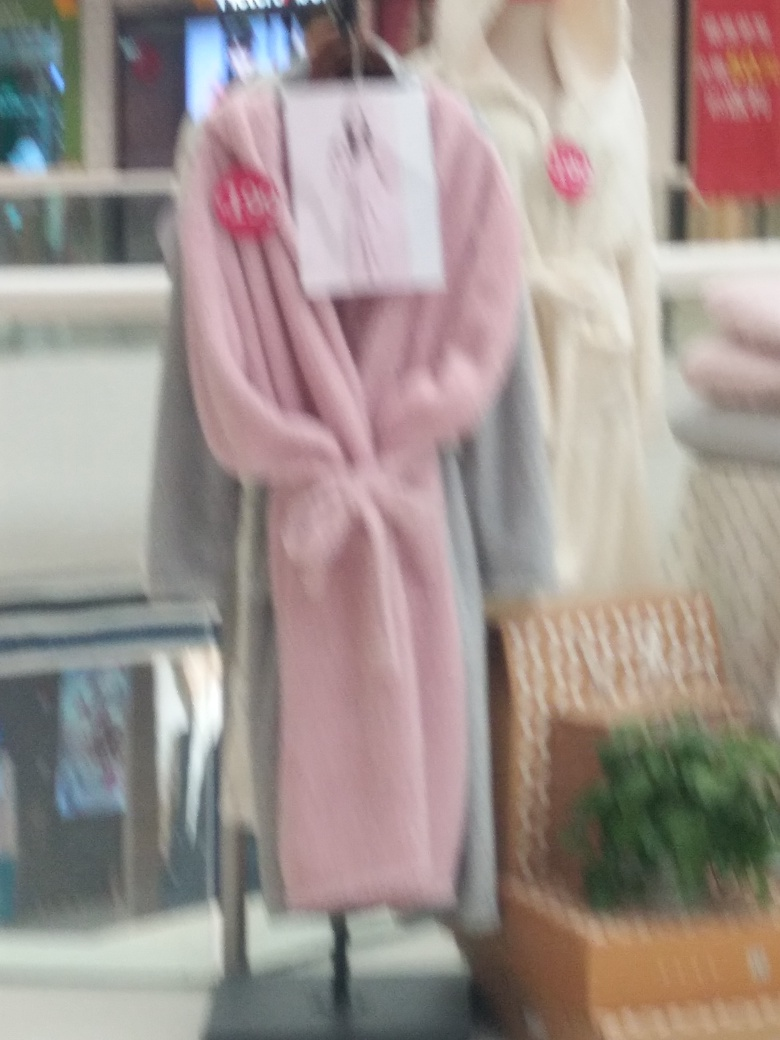Can you describe the items on display? The image portrays a collection of clothing items, with a prominent garment being a pink bathrobe showcased in the foreground, which features a 'new' tag. To the right, there appears to be another item of clothing, likely a bathrobe as well, in a cream or white color. 